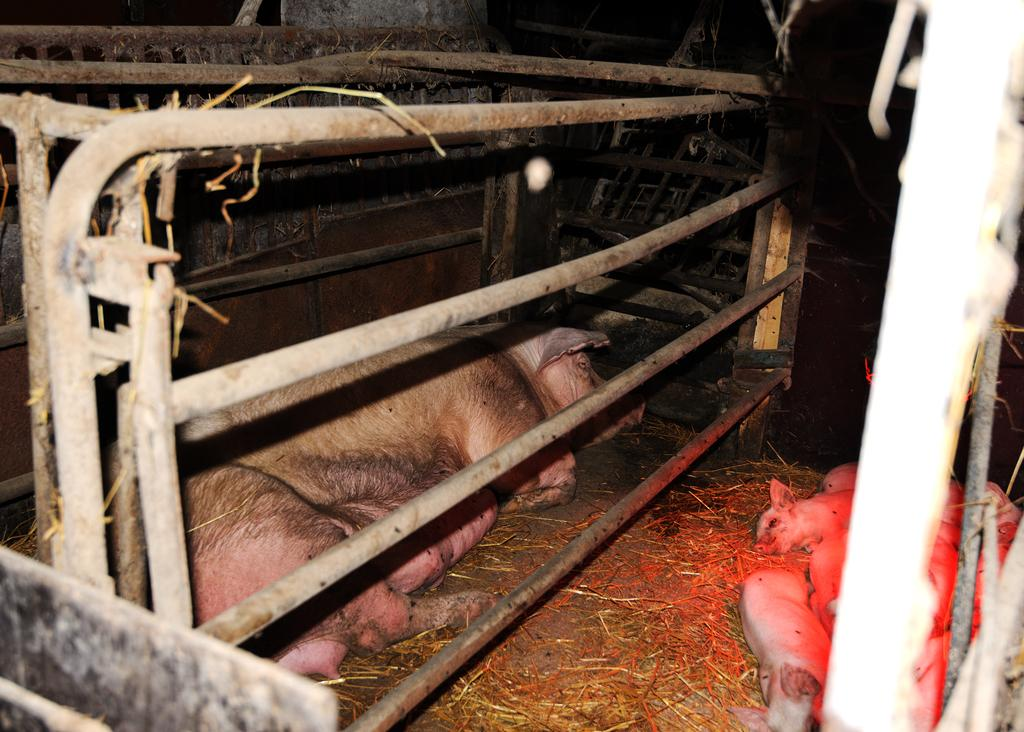What type of animals can be seen on the ground in the image? The image contains animals on the ground, but the specific type of animals cannot be determined from the provided facts. What object is present in the image that is used for holding or displaying items? There is a rod stand in the image, which is used for holding or displaying items. What can be seen in the background of the image? There are scraps visible in the background of the image. What type of apparel is being requested by the animals in the image? There is no indication in the image that the animals are requesting any apparel. What type of support can be seen in the image? The provided facts do not mention any type of support in the image. 